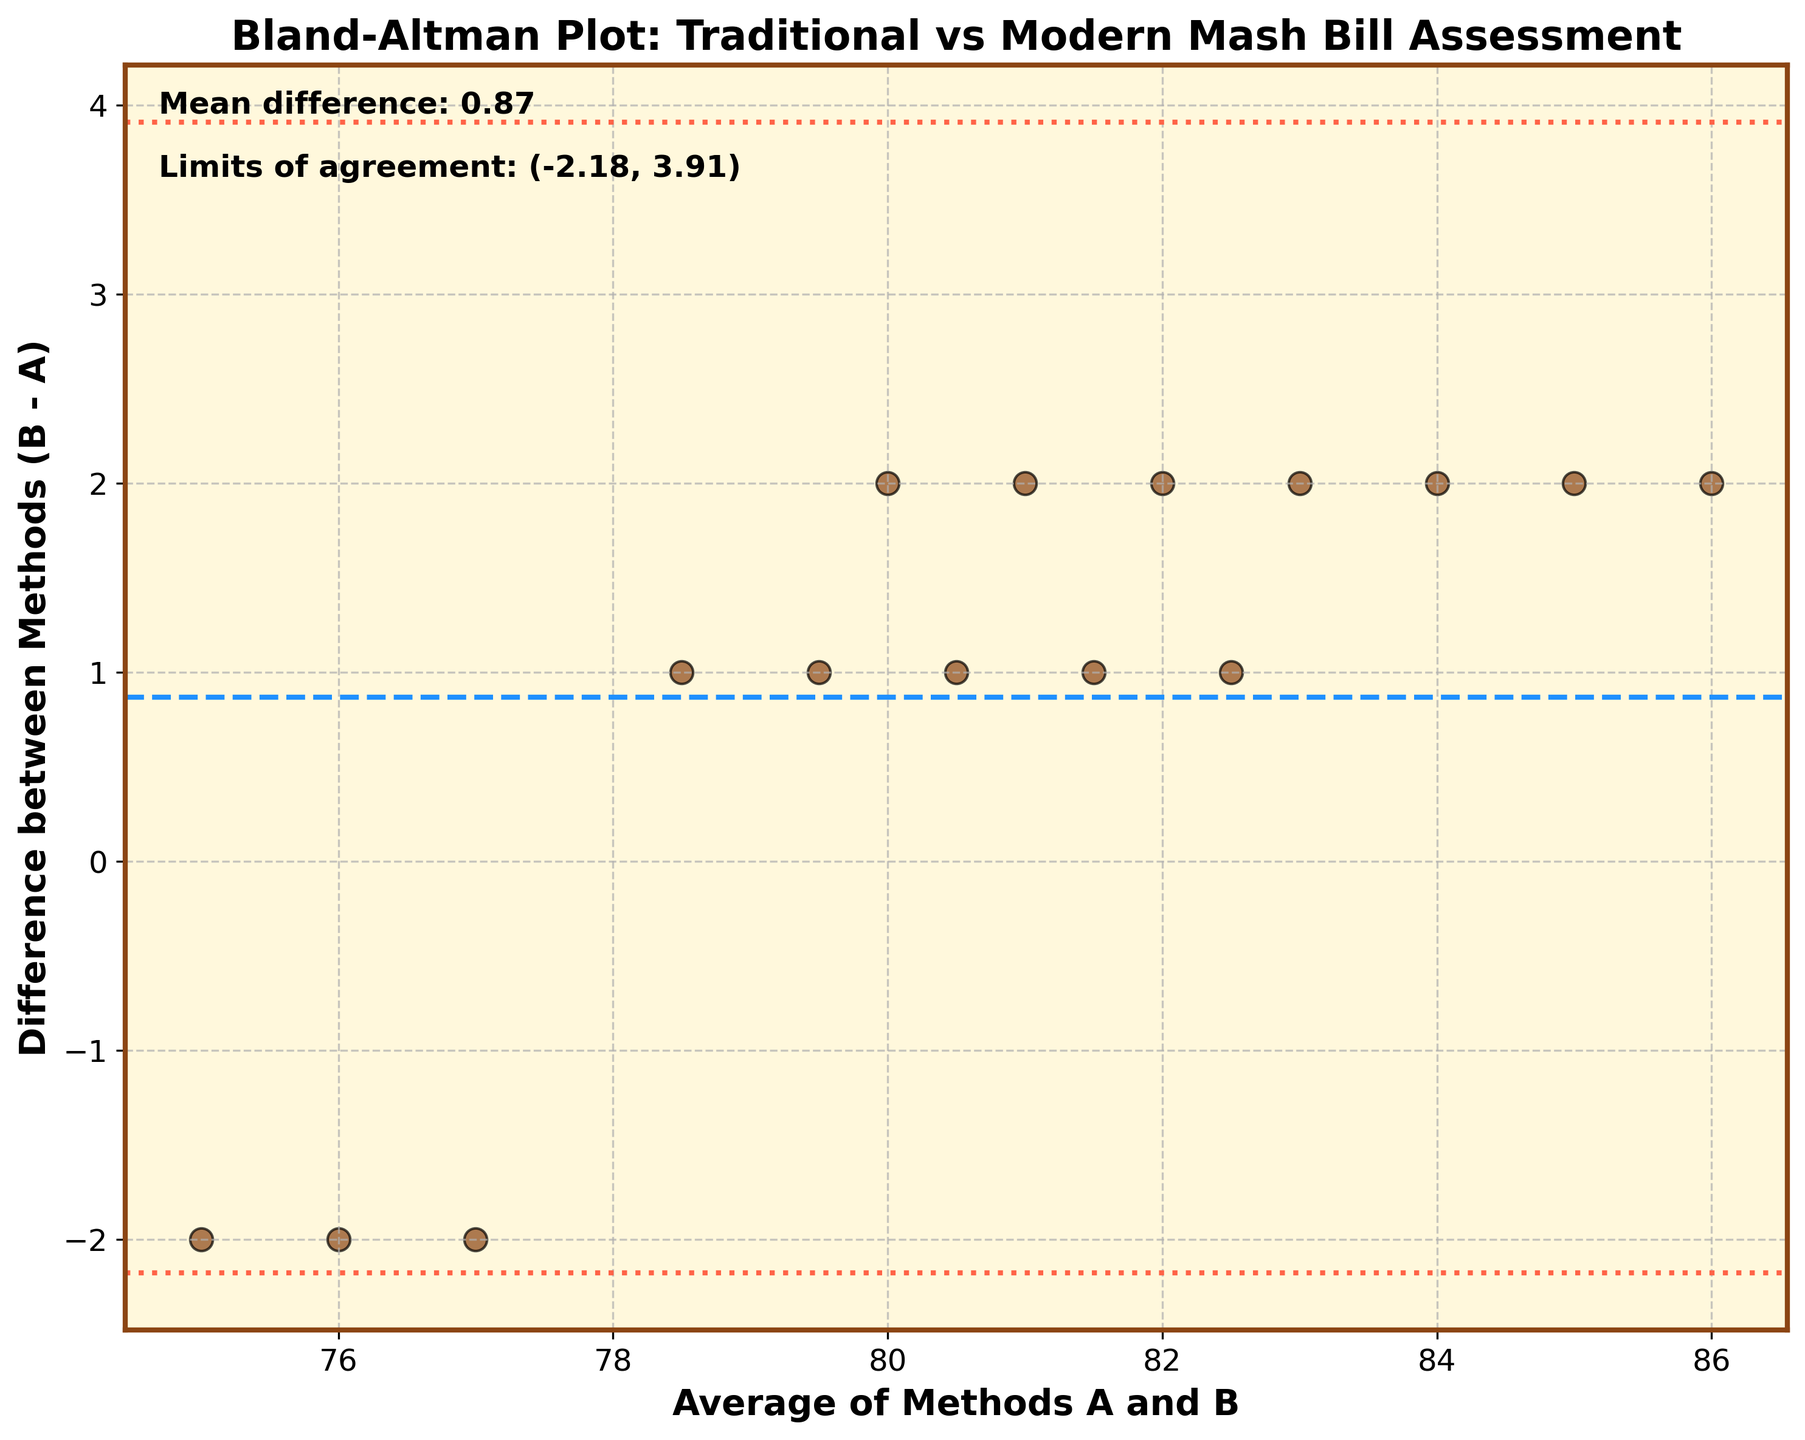What is the title of the Bland-Altman plot? The title of the plot is displayed at the top and reads "Bland-Altman Plot: Traditional vs Modern Mash Bill Assessment".
Answer: Bland-Altman Plot: Traditional vs Modern Mash Bill Assessment How many data points are plotted on the scatterplot? Count the total number of points shown on the plot; each point represents a pair of measurements. By counting, you find 15 data points.
Answer: 15 What is the mean difference between Methods A and B? The mean difference is usually indicated by a horizontal dashed line on the plot; this line is also annotated on the plot. The mean difference noted is 1.07.
Answer: 1.07 What are the limits of agreement on this plot? The limits of agreement are represented by dotted lines and are also annotated on the plot. The range is noted as (-1.53, 3.67).
Answer: (-1.53, 3.67) How many data points fall outside the limits of agreement? Check the number of data points that are above or below the dotted lines representing the limits of agreement. None of the data points fall outside this range.
Answer: 0 What does the color and size of the data points signify? The data points are colored in brown and bordered with black. They are uniformly sized, which indicates no additional attributes (like another variable) are portrayed through color or size differences.
Answer: Uniform color and size, no additional attributes What is the range of the x-axis (Average of Methods A and B)? The x-axis range can be identified by looking at the lower and upper bounds of the x-axis. They start approximately from 75 and go up to about 86.
Answer: 75 to 86 What is the y-axis label and what does it represent? The y-axis label is "Difference between Methods (B - A)", representing the difference values between the measurements from Method B and Method A.
Answer: Difference between Methods (B - A) How much higher is the highest difference compared to the lowest difference? The highest difference is 2, and the lowest is -2. The difference between these two values is 2 - (-2) = 4.
Answer: 4 Are the differences between Methods A and B consistently positive or negative, or mixed? The differences shown vary from positive to negative, indicating that there isn't a consistent bias towards either value being higher.
Answer: Mixed 